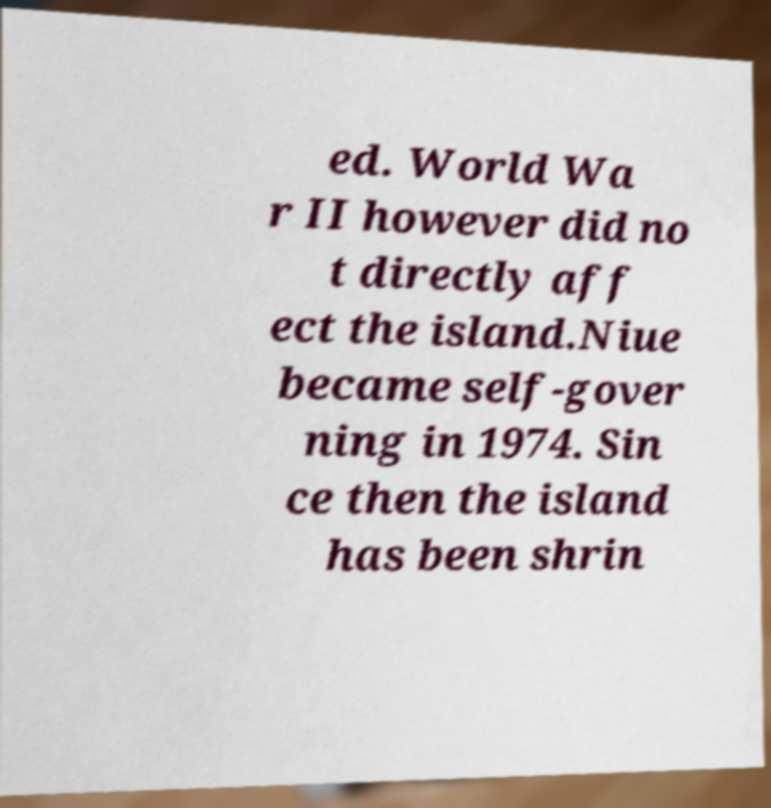There's text embedded in this image that I need extracted. Can you transcribe it verbatim? ed. World Wa r II however did no t directly aff ect the island.Niue became self-gover ning in 1974. Sin ce then the island has been shrin 